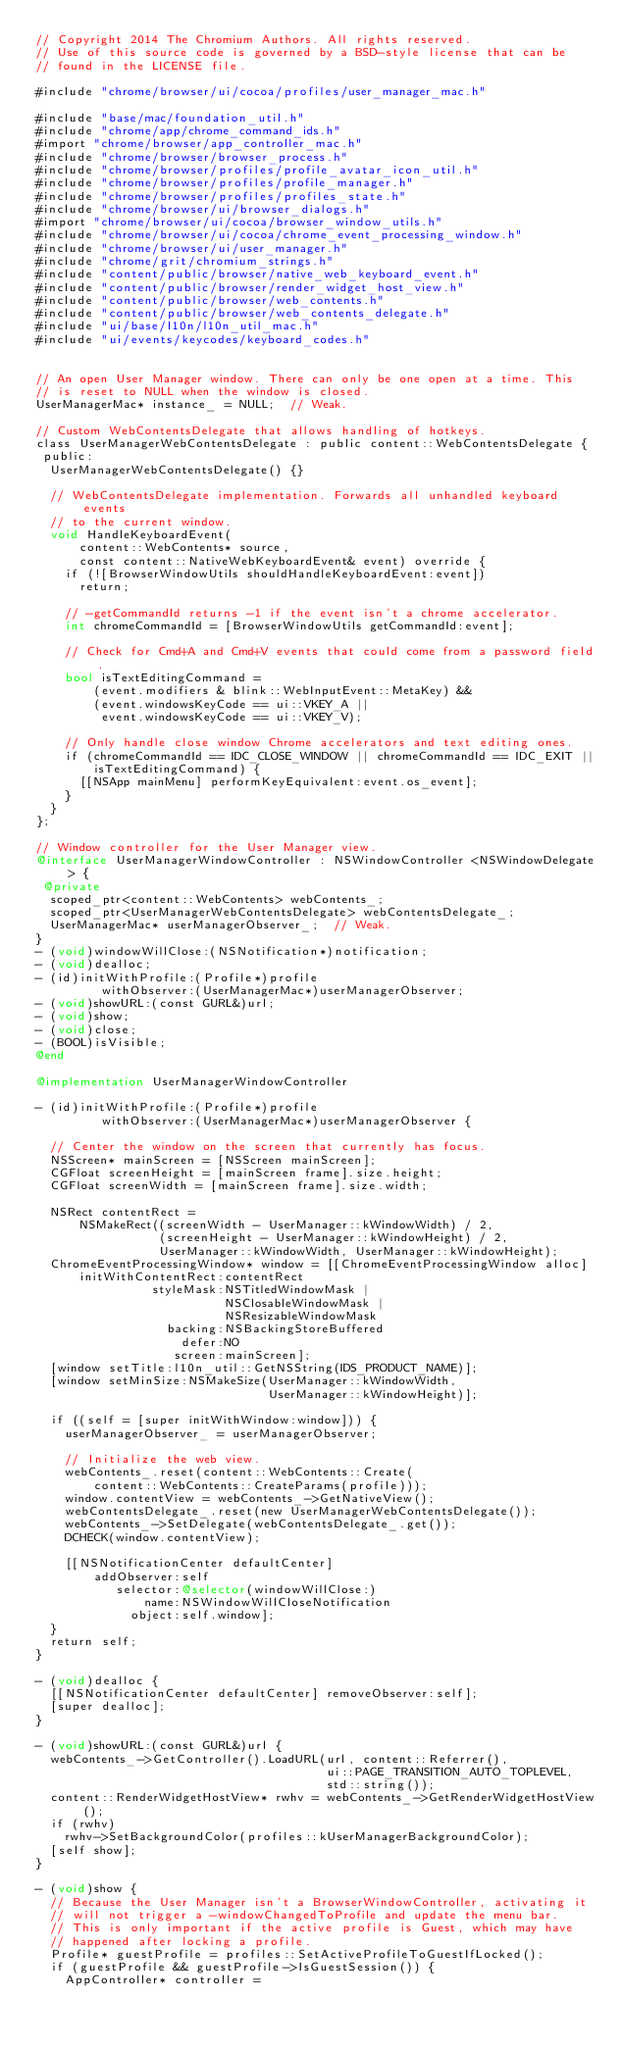<code> <loc_0><loc_0><loc_500><loc_500><_ObjectiveC_>// Copyright 2014 The Chromium Authors. All rights reserved.
// Use of this source code is governed by a BSD-style license that can be
// found in the LICENSE file.

#include "chrome/browser/ui/cocoa/profiles/user_manager_mac.h"

#include "base/mac/foundation_util.h"
#include "chrome/app/chrome_command_ids.h"
#import "chrome/browser/app_controller_mac.h"
#include "chrome/browser/browser_process.h"
#include "chrome/browser/profiles/profile_avatar_icon_util.h"
#include "chrome/browser/profiles/profile_manager.h"
#include "chrome/browser/profiles/profiles_state.h"
#include "chrome/browser/ui/browser_dialogs.h"
#import "chrome/browser/ui/cocoa/browser_window_utils.h"
#include "chrome/browser/ui/cocoa/chrome_event_processing_window.h"
#include "chrome/browser/ui/user_manager.h"
#include "chrome/grit/chromium_strings.h"
#include "content/public/browser/native_web_keyboard_event.h"
#include "content/public/browser/render_widget_host_view.h"
#include "content/public/browser/web_contents.h"
#include "content/public/browser/web_contents_delegate.h"
#include "ui/base/l10n/l10n_util_mac.h"
#include "ui/events/keycodes/keyboard_codes.h"


// An open User Manager window. There can only be one open at a time. This
// is reset to NULL when the window is closed.
UserManagerMac* instance_ = NULL;  // Weak.

// Custom WebContentsDelegate that allows handling of hotkeys.
class UserManagerWebContentsDelegate : public content::WebContentsDelegate {
 public:
  UserManagerWebContentsDelegate() {}

  // WebContentsDelegate implementation. Forwards all unhandled keyboard events
  // to the current window.
  void HandleKeyboardEvent(
      content::WebContents* source,
      const content::NativeWebKeyboardEvent& event) override {
    if (![BrowserWindowUtils shouldHandleKeyboardEvent:event])
      return;

    // -getCommandId returns -1 if the event isn't a chrome accelerator.
    int chromeCommandId = [BrowserWindowUtils getCommandId:event];

    // Check for Cmd+A and Cmd+V events that could come from a password field.
    bool isTextEditingCommand =
        (event.modifiers & blink::WebInputEvent::MetaKey) &&
        (event.windowsKeyCode == ui::VKEY_A ||
         event.windowsKeyCode == ui::VKEY_V);

    // Only handle close window Chrome accelerators and text editing ones.
    if (chromeCommandId == IDC_CLOSE_WINDOW || chromeCommandId == IDC_EXIT ||
        isTextEditingCommand) {
      [[NSApp mainMenu] performKeyEquivalent:event.os_event];
    }
  }
};

// Window controller for the User Manager view.
@interface UserManagerWindowController : NSWindowController <NSWindowDelegate> {
 @private
  scoped_ptr<content::WebContents> webContents_;
  scoped_ptr<UserManagerWebContentsDelegate> webContentsDelegate_;
  UserManagerMac* userManagerObserver_;  // Weak.
}
- (void)windowWillClose:(NSNotification*)notification;
- (void)dealloc;
- (id)initWithProfile:(Profile*)profile
         withObserver:(UserManagerMac*)userManagerObserver;
- (void)showURL:(const GURL&)url;
- (void)show;
- (void)close;
- (BOOL)isVisible;
@end

@implementation UserManagerWindowController

- (id)initWithProfile:(Profile*)profile
         withObserver:(UserManagerMac*)userManagerObserver {

  // Center the window on the screen that currently has focus.
  NSScreen* mainScreen = [NSScreen mainScreen];
  CGFloat screenHeight = [mainScreen frame].size.height;
  CGFloat screenWidth = [mainScreen frame].size.width;

  NSRect contentRect =
      NSMakeRect((screenWidth - UserManager::kWindowWidth) / 2,
                 (screenHeight - UserManager::kWindowHeight) / 2,
                 UserManager::kWindowWidth, UserManager::kWindowHeight);
  ChromeEventProcessingWindow* window = [[ChromeEventProcessingWindow alloc]
      initWithContentRect:contentRect
                styleMask:NSTitledWindowMask |
                          NSClosableWindowMask |
                          NSResizableWindowMask
                  backing:NSBackingStoreBuffered
                    defer:NO
                   screen:mainScreen];
  [window setTitle:l10n_util::GetNSString(IDS_PRODUCT_NAME)];
  [window setMinSize:NSMakeSize(UserManager::kWindowWidth,
                                UserManager::kWindowHeight)];

  if ((self = [super initWithWindow:window])) {
    userManagerObserver_ = userManagerObserver;

    // Initialize the web view.
    webContents_.reset(content::WebContents::Create(
        content::WebContents::CreateParams(profile)));
    window.contentView = webContents_->GetNativeView();
    webContentsDelegate_.reset(new UserManagerWebContentsDelegate());
    webContents_->SetDelegate(webContentsDelegate_.get());
    DCHECK(window.contentView);

    [[NSNotificationCenter defaultCenter]
        addObserver:self
           selector:@selector(windowWillClose:)
               name:NSWindowWillCloseNotification
             object:self.window];
  }
  return self;
}

- (void)dealloc {
  [[NSNotificationCenter defaultCenter] removeObserver:self];
  [super dealloc];
}

- (void)showURL:(const GURL&)url {
  webContents_->GetController().LoadURL(url, content::Referrer(),
                                        ui::PAGE_TRANSITION_AUTO_TOPLEVEL,
                                        std::string());
  content::RenderWidgetHostView* rwhv = webContents_->GetRenderWidgetHostView();
  if (rwhv)
    rwhv->SetBackgroundColor(profiles::kUserManagerBackgroundColor);
  [self show];
}

- (void)show {
  // Because the User Manager isn't a BrowserWindowController, activating it
  // will not trigger a -windowChangedToProfile and update the menu bar.
  // This is only important if the active profile is Guest, which may have
  // happened after locking a profile.
  Profile* guestProfile = profiles::SetActiveProfileToGuestIfLocked();
  if (guestProfile && guestProfile->IsGuestSession()) {
    AppController* controller =</code> 